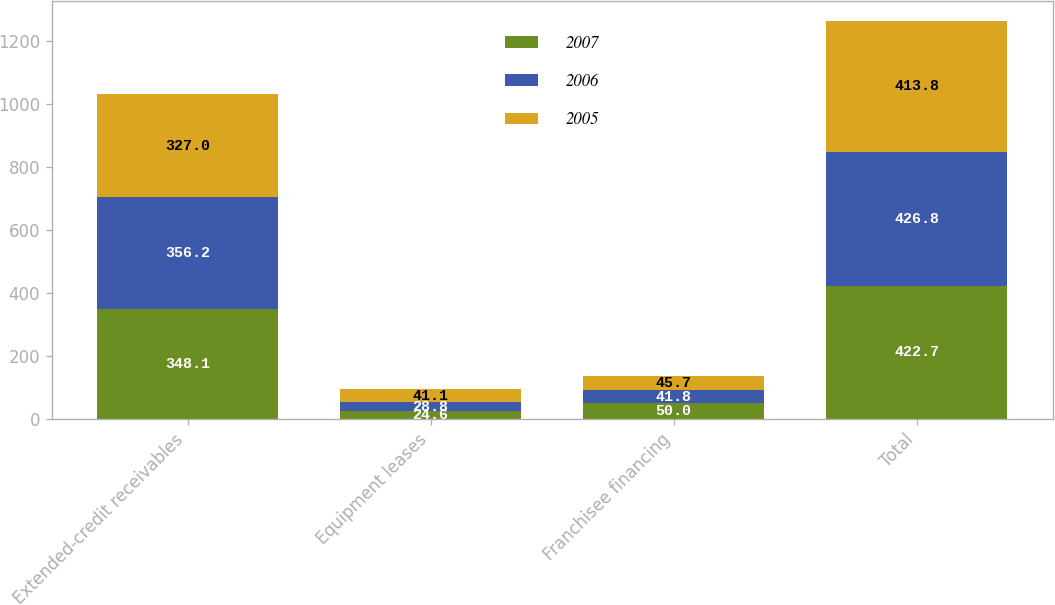Convert chart. <chart><loc_0><loc_0><loc_500><loc_500><stacked_bar_chart><ecel><fcel>Extended-credit receivables<fcel>Equipment leases<fcel>Franchisee financing<fcel>Total<nl><fcel>2007<fcel>348.1<fcel>24.6<fcel>50<fcel>422.7<nl><fcel>2006<fcel>356.2<fcel>28.8<fcel>41.8<fcel>426.8<nl><fcel>2005<fcel>327<fcel>41.1<fcel>45.7<fcel>413.8<nl></chart> 